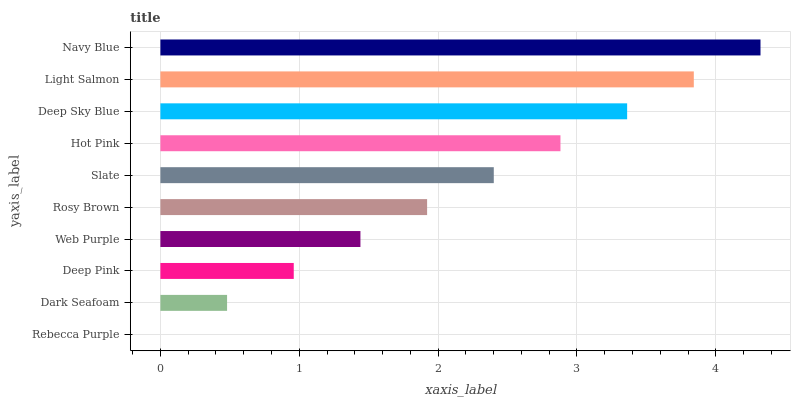Is Rebecca Purple the minimum?
Answer yes or no. Yes. Is Navy Blue the maximum?
Answer yes or no. Yes. Is Dark Seafoam the minimum?
Answer yes or no. No. Is Dark Seafoam the maximum?
Answer yes or no. No. Is Dark Seafoam greater than Rebecca Purple?
Answer yes or no. Yes. Is Rebecca Purple less than Dark Seafoam?
Answer yes or no. Yes. Is Rebecca Purple greater than Dark Seafoam?
Answer yes or no. No. Is Dark Seafoam less than Rebecca Purple?
Answer yes or no. No. Is Slate the high median?
Answer yes or no. Yes. Is Rosy Brown the low median?
Answer yes or no. Yes. Is Navy Blue the high median?
Answer yes or no. No. Is Light Salmon the low median?
Answer yes or no. No. 